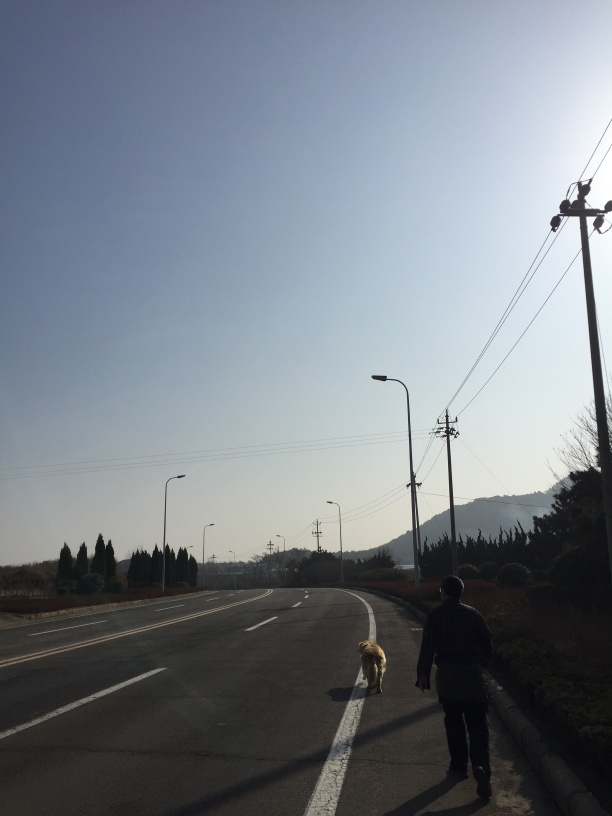Is there anything in the image that might indicate the location where this was taken? There are no definitive landmarks that indicate a specific location, but the style of the street lamps and the design of the electrical poles might suggest a suburban area in East Asia. 